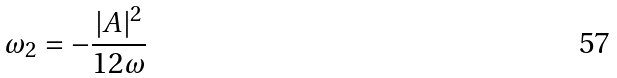<formula> <loc_0><loc_0><loc_500><loc_500>\omega _ { 2 } = - \frac { | A | ^ { 2 } } { 1 2 \omega }</formula> 